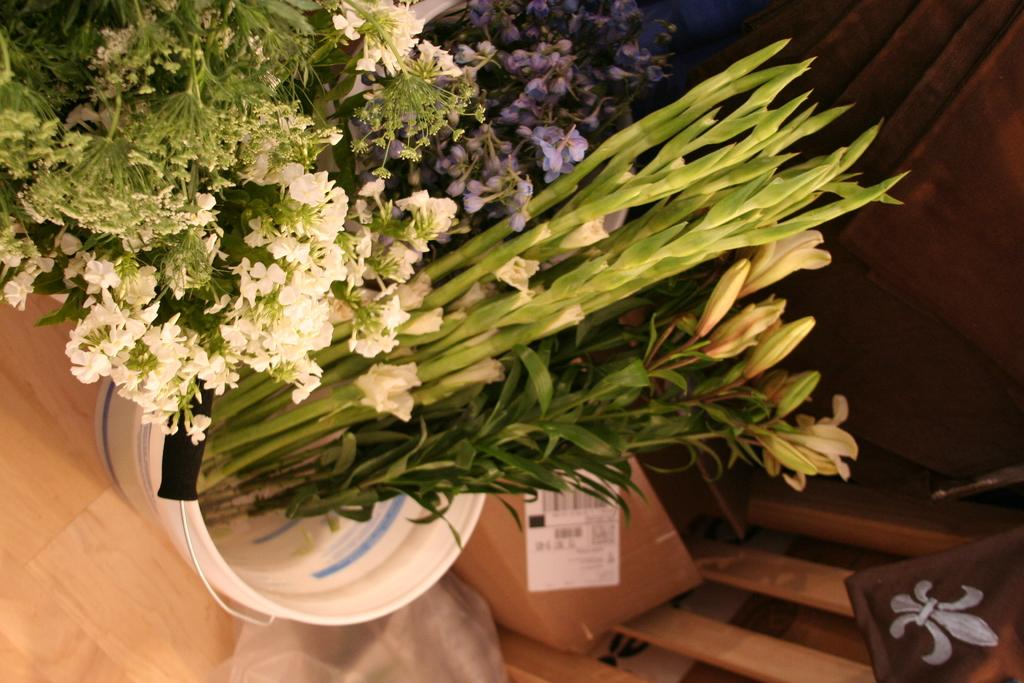What type of living organisms can be seen in the image? Plants and flowers are visible in the image. Can you describe the specific floral elements in the image? Yes, there are flowers in the image. What architectural feature can be seen in the background of the image? There is a door visible in the background of the image. What type of camera is being used to take the picture of the plants and flowers? There is no camera present in the image, as it is a photograph of the plants and flowers. How many dogs are visible in the image? There are no dogs present in the image. 